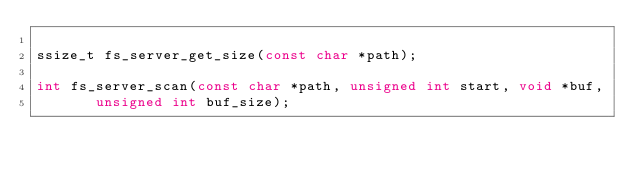<code> <loc_0><loc_0><loc_500><loc_500><_C_>
ssize_t fs_server_get_size(const char *path);

int fs_server_scan(const char *path, unsigned int start, void *buf,
		   unsigned int buf_size);
</code> 